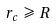Convert formula to latex. <formula><loc_0><loc_0><loc_500><loc_500>r _ { c } \, \geqslant \, R</formula> 